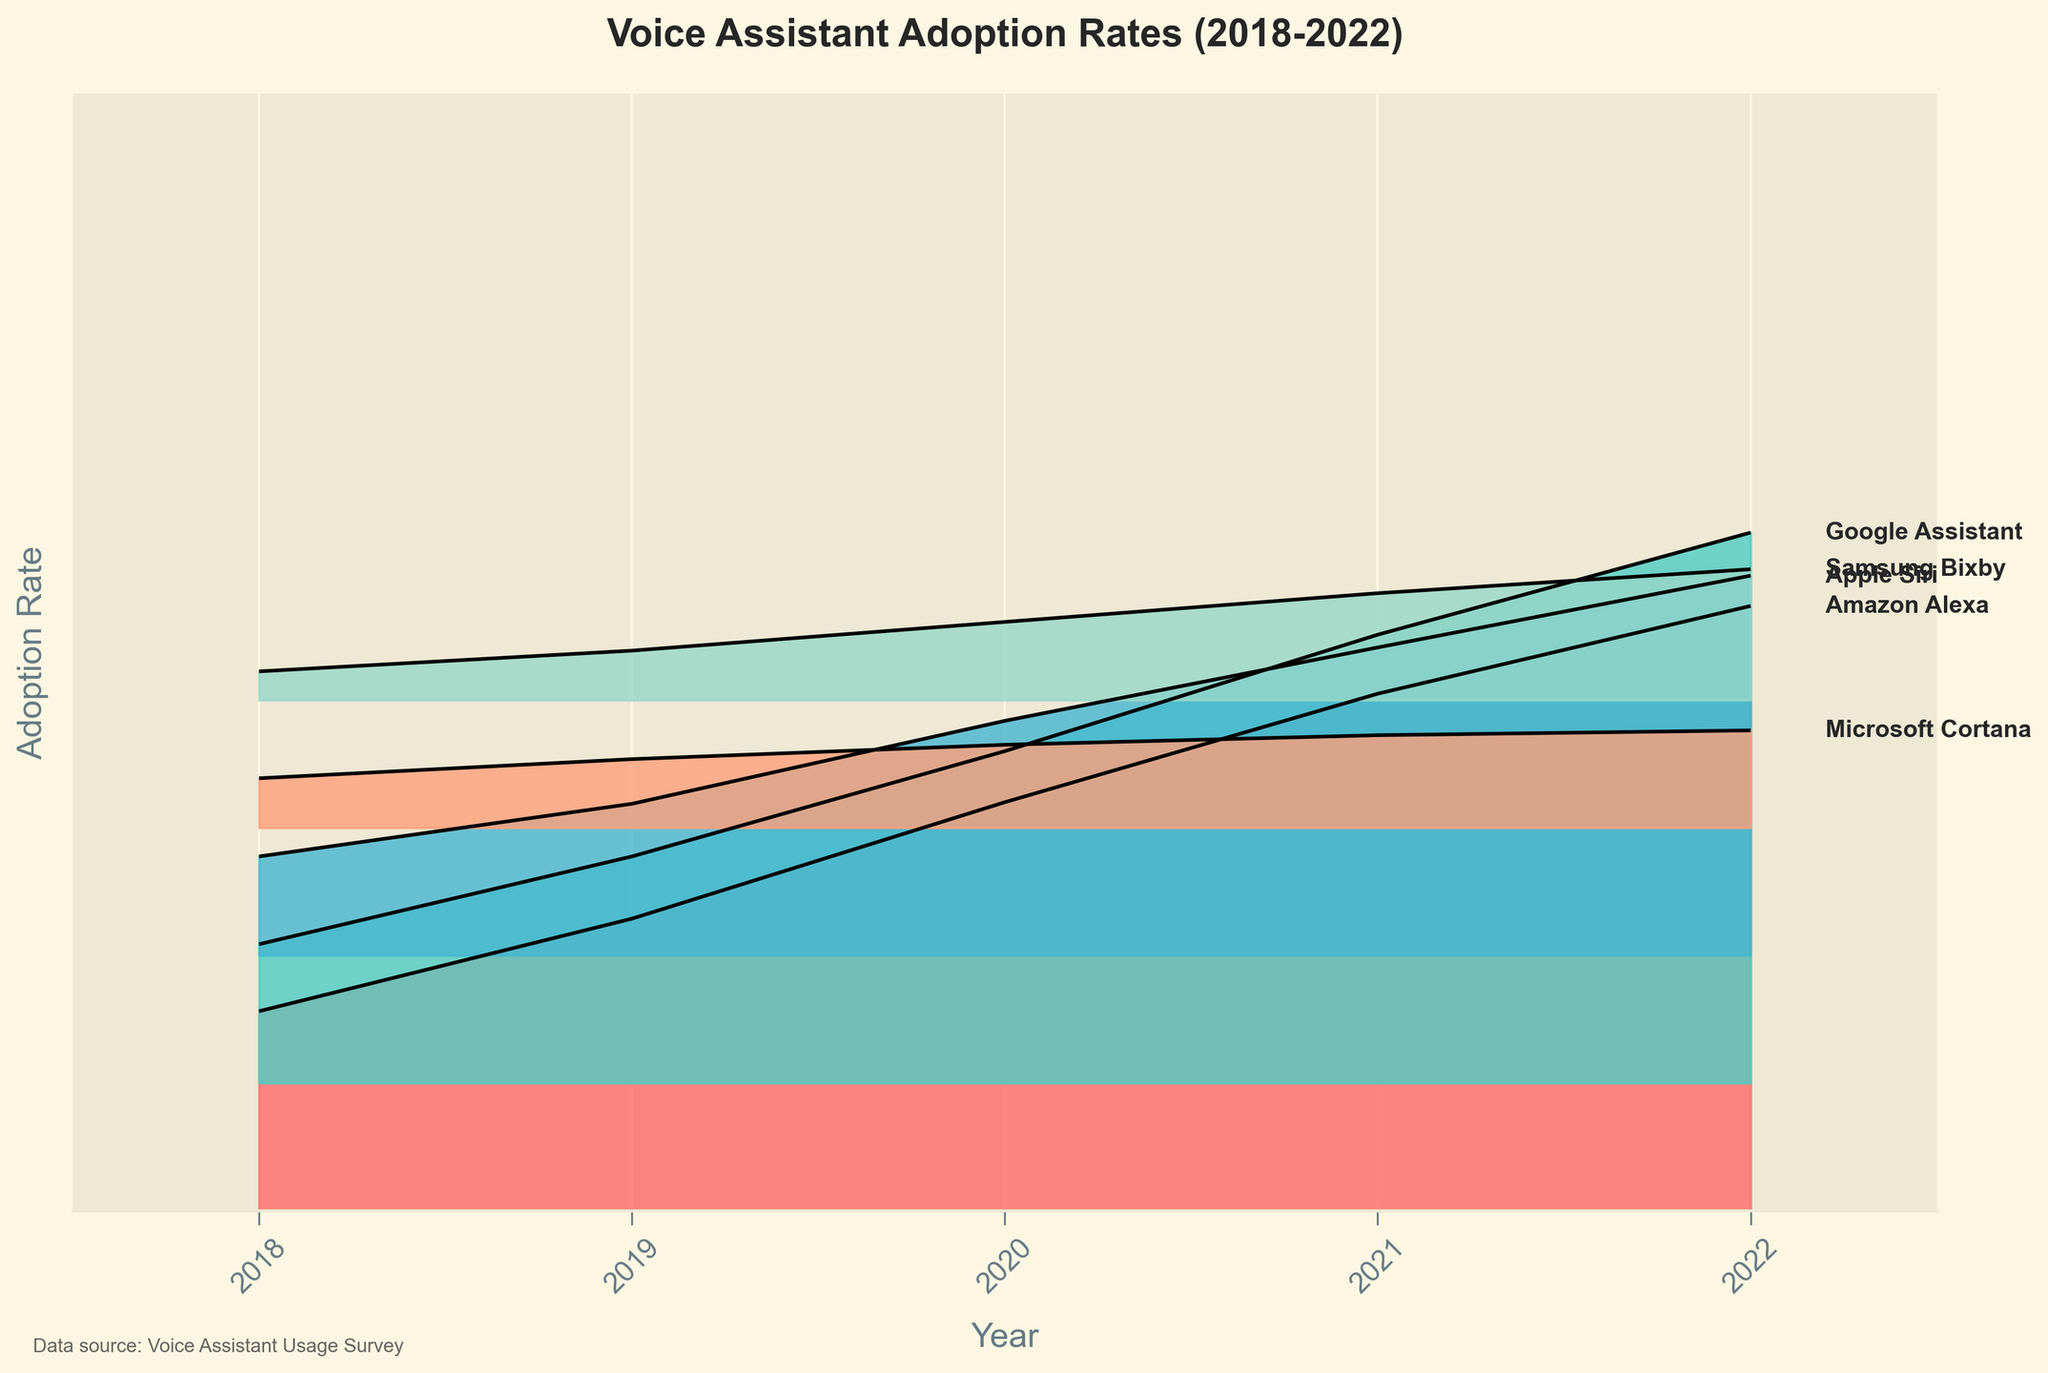What is the title of the plot? The title is at the top of the plot area and typically summarizes the data displayed. In this case, it reads "Voice Assistant Adoption Rates (2018-2022)"
Answer: Voice Assistant Adoption Rates (2018-2022) Which voice assistant has the highest adoption rate in 2022? From the graphical trend lines, look for the highest point in 2022 and the corresponding label. Amazon Alexa hits the highest rate.
Answer: Amazon Alexa How did the adoption rate of Google Assistant change from 2018 to 2022? Observe the plotted line for Google Assistant from 2018 to 2022. Note the increase in height from around 8.7 in 2018 to 34.5 in 2022.
Answer: Increased What was the adoption rate difference between Apple Siri and Microsoft Cortana in 2021? Find the adoption rates for Apple Siri (19.3) and Microsoft Cortana (5.8) in 2021 and subtract the smaller from the larger. The difference is 19.3 - 5.8.
Answer: 13.5 Which platform consistently showed the lowest adoption rate between 2018 and 2022? Observe all trend lines for the lowest placement consistently each year. Samsung Bixby often has the lowest rates throughout the years.
Answer: Samsung Bixby If you combine the adoption rates of all platforms in 2020, what do you get? Sum all the adoption rates for 2020: 25.6 (Amazon Alexa) + 20.8 (Google Assistant) + 14.7 (Apple Siri) + 5.2 (Microsoft Cortana) + 4.9 (Samsung Bixby).
Answer: 71.2 Among the listed years, which year had the highest combined adoption rates for all platforms? Sum the rates for all platforms for each year and compare. The highest sum will indicate the year with the highest combined adoption rate. 2022 has the highest sum.
Answer: 2022 Did any voice assistant’s adoption rate decrease at any point in the given period? Examine the trend lines for any downward movement. All lines consistently show an increase over the years.
Answer: No Which voice assistants' adoption rates surpassed 20% by 2021? Look at the lines for 2021 and check which platforms crossed the 20% mark: Amazon Alexa and Google Assistant did.
Answer: Amazon Alexa, Google Assistant By how much did the adoption rate of Amazon Alexa increase from 2018 to 2022? Subtract 2018's rate (12.5) from 2022's rate (37.9). The increase is 37.9 - 12.5.
Answer: 25.4 